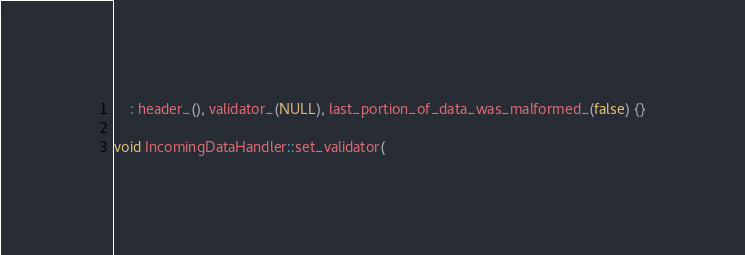Convert code to text. <code><loc_0><loc_0><loc_500><loc_500><_C++_>    : header_(), validator_(NULL), last_portion_of_data_was_malformed_(false) {}

void IncomingDataHandler::set_validator(</code> 